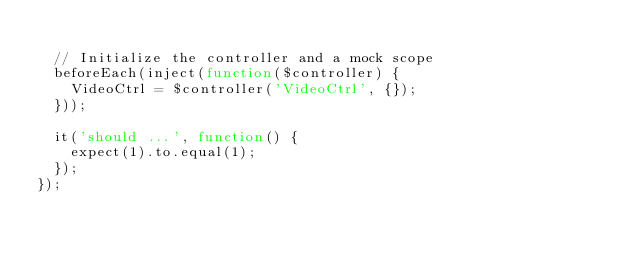Convert code to text. <code><loc_0><loc_0><loc_500><loc_500><_JavaScript_>
  // Initialize the controller and a mock scope
  beforeEach(inject(function($controller) {
    VideoCtrl = $controller('VideoCtrl', {});
  }));

  it('should ...', function() {
    expect(1).to.equal(1);
  });
});
</code> 